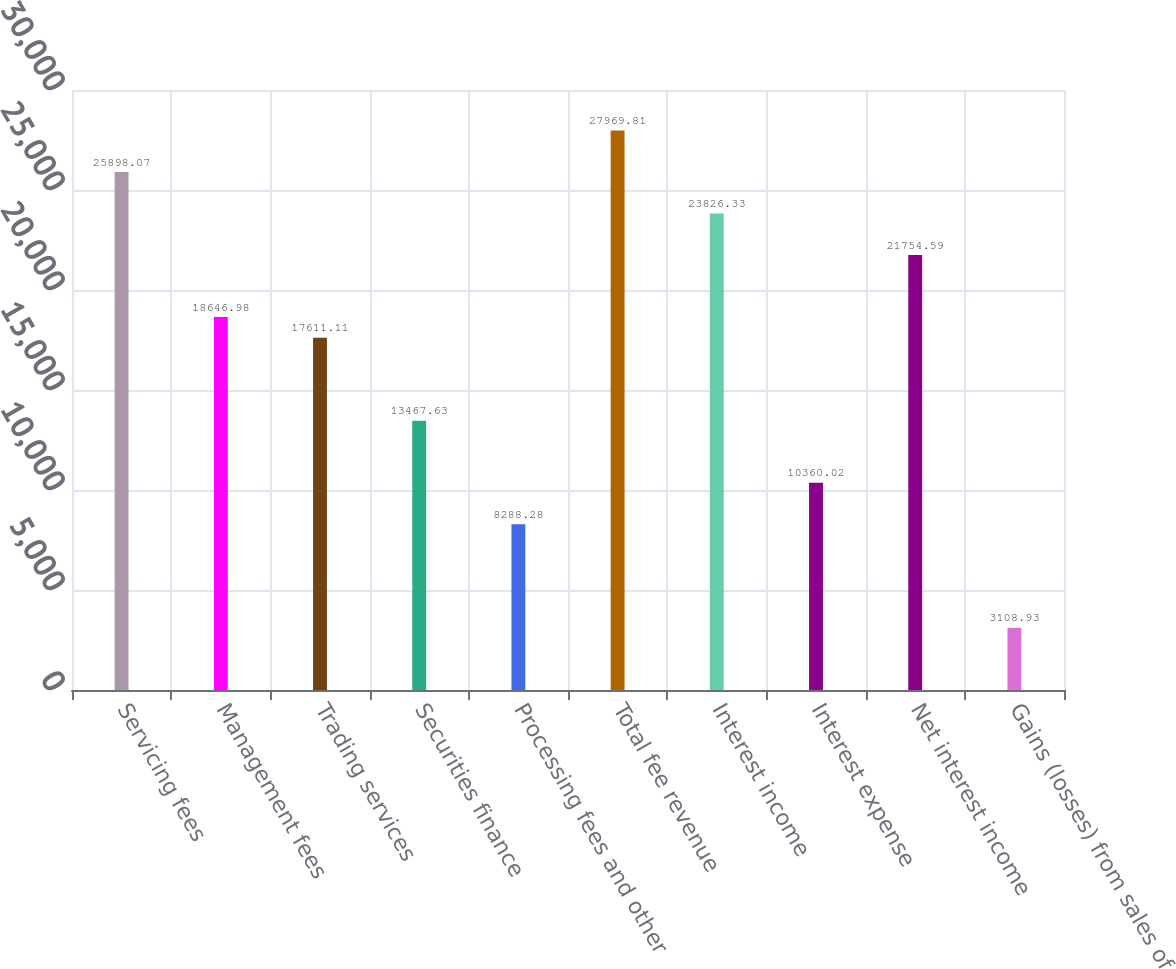<chart> <loc_0><loc_0><loc_500><loc_500><bar_chart><fcel>Servicing fees<fcel>Management fees<fcel>Trading services<fcel>Securities finance<fcel>Processing fees and other<fcel>Total fee revenue<fcel>Interest income<fcel>Interest expense<fcel>Net interest income<fcel>Gains (losses) from sales of<nl><fcel>25898.1<fcel>18647<fcel>17611.1<fcel>13467.6<fcel>8288.28<fcel>27969.8<fcel>23826.3<fcel>10360<fcel>21754.6<fcel>3108.93<nl></chart> 